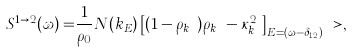<formula> <loc_0><loc_0><loc_500><loc_500>S ^ { 1 \rightarrow 2 } ( \omega ) = & \frac { 1 } { \rho _ { 0 } } { N ( k _ { E } ) } \left [ ( 1 - \rho _ { k _ { E } } ) \rho _ { k _ { E } } - \kappa _ { k _ { E } } ^ { 2 } \right ] _ { E = ( \omega - \delta _ { 1 2 } ) } \ > ,</formula> 